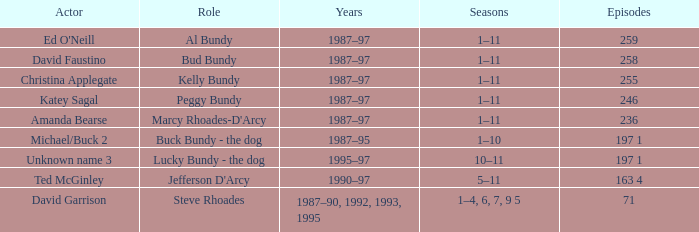Write the full table. {'header': ['Actor', 'Role', 'Years', 'Seasons', 'Episodes'], 'rows': [["Ed O'Neill", 'Al Bundy', '1987–97', '1–11', '259'], ['David Faustino', 'Bud Bundy', '1987–97', '1–11', '258'], ['Christina Applegate', 'Kelly Bundy', '1987–97', '1–11', '255'], ['Katey Sagal', 'Peggy Bundy', '1987–97', '1–11', '246'], ['Amanda Bearse', "Marcy Rhoades-D'Arcy", '1987–97', '1–11', '236'], ['Michael/Buck 2', 'Buck Bundy - the dog', '1987–95', '1–10', '197 1'], ['Unknown name 3', 'Lucky Bundy - the dog', '1995–97', '10–11', '197 1'], ['Ted McGinley', "Jefferson D'Arcy", '1990–97', '5–11', '163 4'], ['David Garrison', 'Steve Rhoades', '1987–90, 1992, 1993, 1995', '1–4, 6, 7, 9 5', '71']]} How numerous are the episodes with david faustino's appearance? 258.0. 